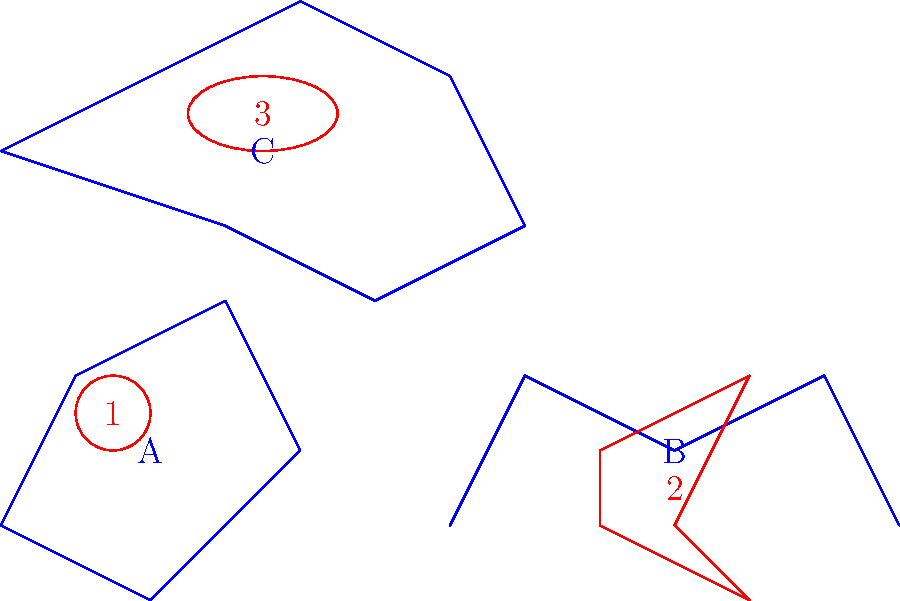Match the Star Wars spacecraft (numbered 1-3) with their corresponding constellations (labeled A-C) based on their visual similarity and positioning in the image. To solve this visual puzzle, we need to analyze the shapes and positions of both the constellations and the Star Wars spacecraft:

1. Constellation A (Orion):
   - Has a roughly pentagonal shape with an extension at the top.
   - Closest matching spacecraft is 1 (TIE Fighter), which is circular and positioned near the center of the constellation.

2. Constellation B (Cassiopeia):
   - Has a distinct W or M shape.
   - Closest matching spacecraft is 2 (X-Wing), which has a similar angular shape and is positioned directly below the constellation.

3. Constellation C (Ursa Major):
   - Has a shape resembling a ladle or dipper.
   - Closest matching spacecraft is 3 (Millennium Falcon), which has an oval shape similar to the "bowl" of the dipper and is positioned within the constellation.

By matching the shapes and positions, we can conclude:
- Spacecraft 1 (TIE Fighter) corresponds to Constellation A (Orion)
- Spacecraft 2 (X-Wing) corresponds to Constellation B (Cassiopeia)
- Spacecraft 3 (Millennium Falcon) corresponds to Constellation C (Ursa Major)
Answer: 1-A, 2-B, 3-C 